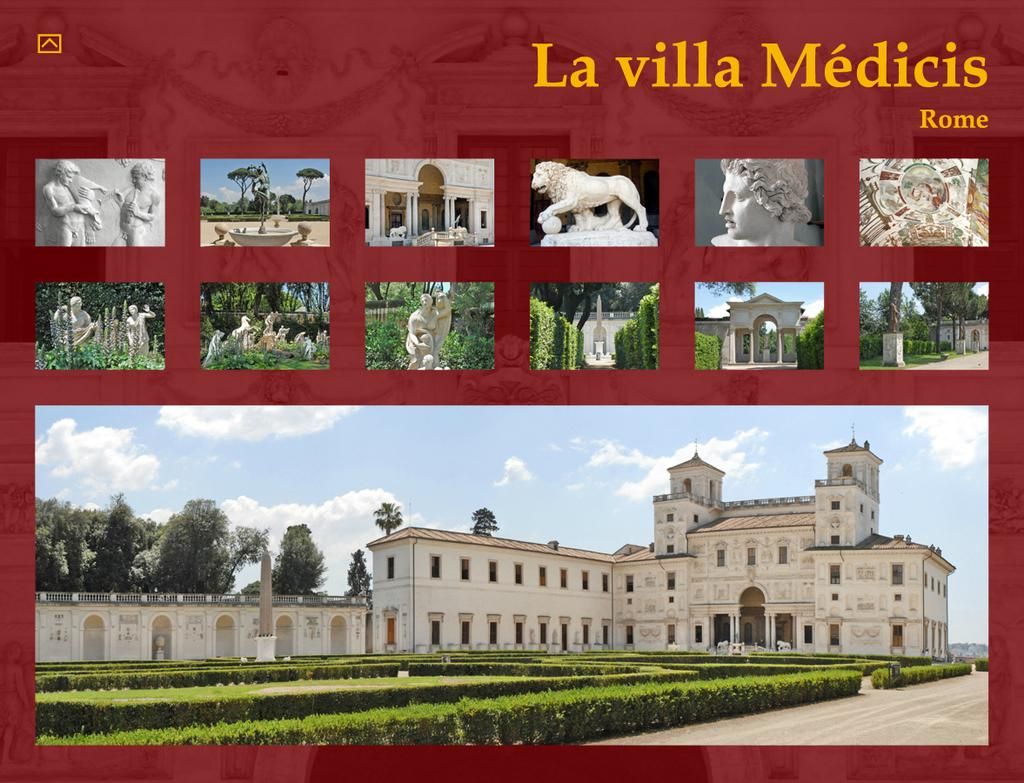What type of visual representation is the image? The image is a poster. What type of terrain is depicted in the poster? There is ground depicted in the poster. What type of vegetation is present in the poster? Plants and trees are visible in the poster. Are there any structures depicted in the poster? Yes, there is at least one building in the poster. What type of artwork is depicted in the poster? Sculptures are depicted in the poster. What part of the natural environment is visible in the poster? The sky is visible in the poster. What type of weather is suggested by the sky in the poster? Clouds are present in the sky of the poster, suggesting a partly cloudy day. Is there any text present on the poster? Yes, there is text on the poster. How many snails can be seen crawling on the sculptures in the poster? There are no snails depicted on the sculptures in the poster. Who is the writer of the text on the poster? The poster does not indicate the author of the text, and therefore it cannot be determined from the image. 